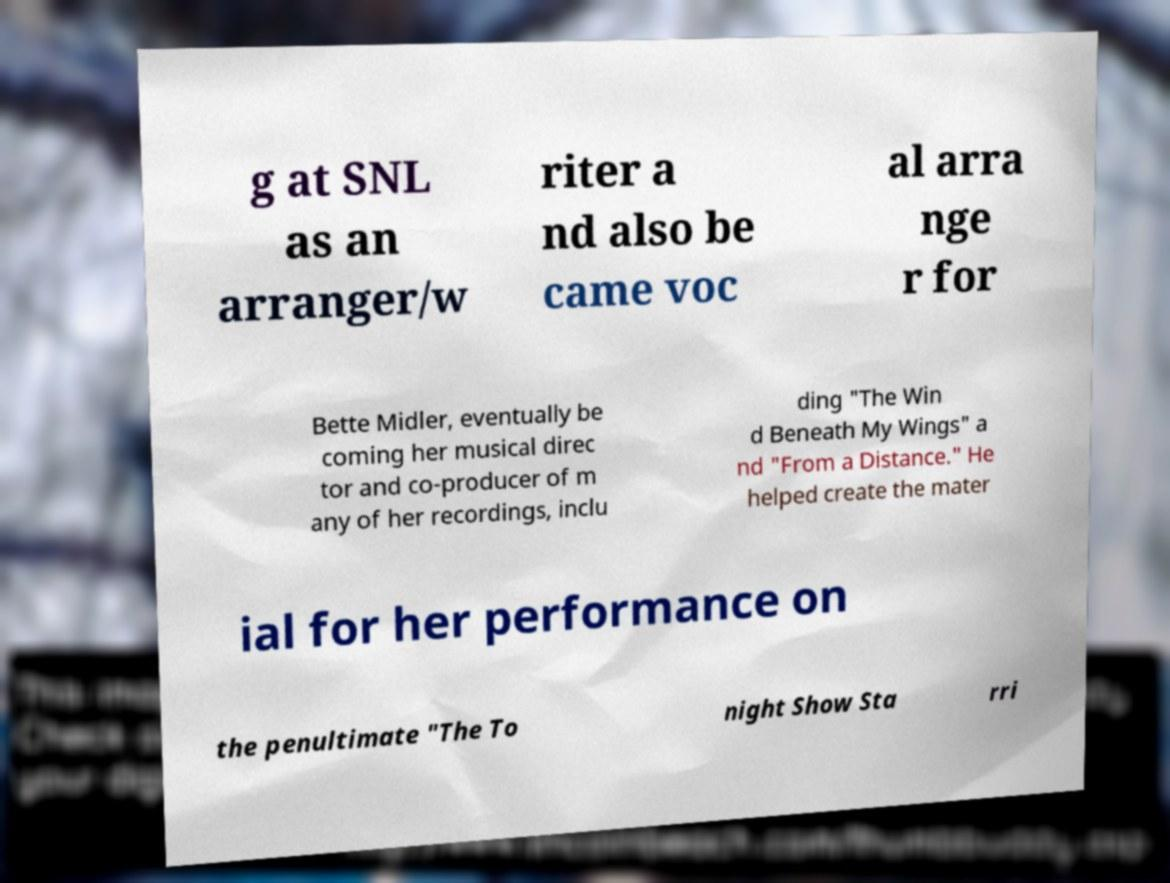Could you extract and type out the text from this image? g at SNL as an arranger/w riter a nd also be came voc al arra nge r for Bette Midler, eventually be coming her musical direc tor and co-producer of m any of her recordings, inclu ding "The Win d Beneath My Wings" a nd "From a Distance." He helped create the mater ial for her performance on the penultimate "The To night Show Sta rri 